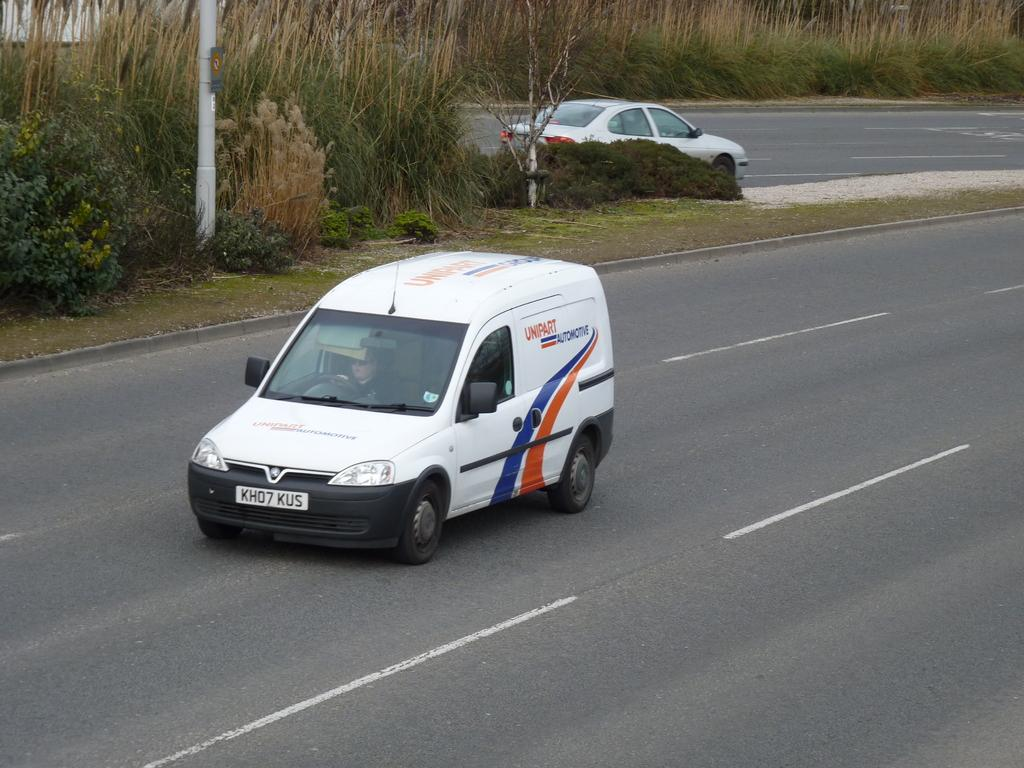How many vehicles can be seen on the road in the image? There are two vehicles on the road in the image. What is located next to the road? There is a pavement to the side of the road. What can be found on the pavement? There are plants and grass on the pavement. What structure is present in the image? There is a pole in the image. What type of vegetation is visible in the image? There is a tree visible in the image. What type of fruit is hanging from the tree in the image? There is no fruit visible on the tree in the image. Are there any birds flying around the vehicles in the image? There is no mention of birds in the image, so we cannot determine if they are present or not. 